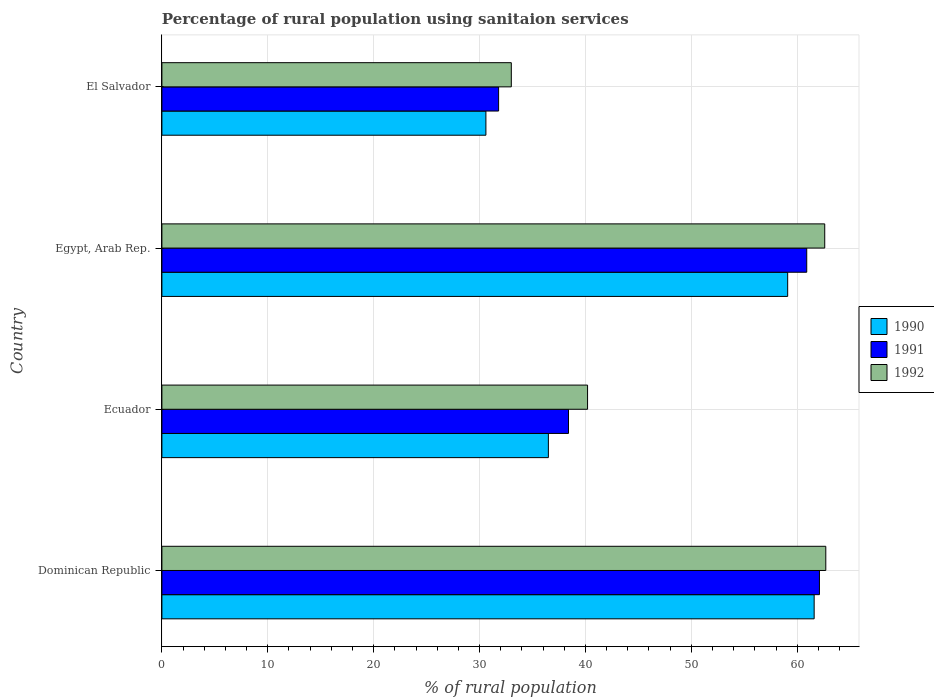How many groups of bars are there?
Your answer should be compact. 4. How many bars are there on the 4th tick from the bottom?
Your response must be concise. 3. What is the label of the 3rd group of bars from the top?
Your response must be concise. Ecuador. What is the percentage of rural population using sanitaion services in 1991 in Ecuador?
Give a very brief answer. 38.4. Across all countries, what is the maximum percentage of rural population using sanitaion services in 1991?
Offer a very short reply. 62.1. Across all countries, what is the minimum percentage of rural population using sanitaion services in 1991?
Ensure brevity in your answer.  31.8. In which country was the percentage of rural population using sanitaion services in 1990 maximum?
Offer a terse response. Dominican Republic. In which country was the percentage of rural population using sanitaion services in 1990 minimum?
Offer a terse response. El Salvador. What is the total percentage of rural population using sanitaion services in 1992 in the graph?
Offer a very short reply. 198.5. What is the difference between the percentage of rural population using sanitaion services in 1992 in Ecuador and that in El Salvador?
Offer a very short reply. 7.2. What is the difference between the percentage of rural population using sanitaion services in 1990 in El Salvador and the percentage of rural population using sanitaion services in 1992 in Dominican Republic?
Provide a succinct answer. -32.1. What is the average percentage of rural population using sanitaion services in 1990 per country?
Your response must be concise. 46.95. What is the difference between the percentage of rural population using sanitaion services in 1990 and percentage of rural population using sanitaion services in 1991 in Egypt, Arab Rep.?
Your answer should be compact. -1.8. In how many countries, is the percentage of rural population using sanitaion services in 1991 greater than 36 %?
Provide a succinct answer. 3. What is the ratio of the percentage of rural population using sanitaion services in 1991 in Dominican Republic to that in El Salvador?
Provide a short and direct response. 1.95. Is the difference between the percentage of rural population using sanitaion services in 1990 in Egypt, Arab Rep. and El Salvador greater than the difference between the percentage of rural population using sanitaion services in 1991 in Egypt, Arab Rep. and El Salvador?
Give a very brief answer. No. What is the difference between the highest and the second highest percentage of rural population using sanitaion services in 1992?
Provide a succinct answer. 0.1. What is the difference between the highest and the lowest percentage of rural population using sanitaion services in 1991?
Give a very brief answer. 30.3. In how many countries, is the percentage of rural population using sanitaion services in 1990 greater than the average percentage of rural population using sanitaion services in 1990 taken over all countries?
Ensure brevity in your answer.  2. Are all the bars in the graph horizontal?
Your response must be concise. Yes. How many countries are there in the graph?
Your response must be concise. 4. What is the difference between two consecutive major ticks on the X-axis?
Keep it short and to the point. 10. Does the graph contain any zero values?
Offer a very short reply. No. Does the graph contain grids?
Ensure brevity in your answer.  Yes. Where does the legend appear in the graph?
Offer a terse response. Center right. How many legend labels are there?
Ensure brevity in your answer.  3. How are the legend labels stacked?
Make the answer very short. Vertical. What is the title of the graph?
Provide a succinct answer. Percentage of rural population using sanitaion services. What is the label or title of the X-axis?
Offer a terse response. % of rural population. What is the % of rural population of 1990 in Dominican Republic?
Your response must be concise. 61.6. What is the % of rural population in 1991 in Dominican Republic?
Your answer should be very brief. 62.1. What is the % of rural population of 1992 in Dominican Republic?
Make the answer very short. 62.7. What is the % of rural population in 1990 in Ecuador?
Offer a terse response. 36.5. What is the % of rural population in 1991 in Ecuador?
Make the answer very short. 38.4. What is the % of rural population in 1992 in Ecuador?
Give a very brief answer. 40.2. What is the % of rural population in 1990 in Egypt, Arab Rep.?
Make the answer very short. 59.1. What is the % of rural population of 1991 in Egypt, Arab Rep.?
Your answer should be compact. 60.9. What is the % of rural population of 1992 in Egypt, Arab Rep.?
Your answer should be compact. 62.6. What is the % of rural population of 1990 in El Salvador?
Offer a terse response. 30.6. What is the % of rural population in 1991 in El Salvador?
Provide a short and direct response. 31.8. What is the % of rural population of 1992 in El Salvador?
Provide a succinct answer. 33. Across all countries, what is the maximum % of rural population in 1990?
Your answer should be compact. 61.6. Across all countries, what is the maximum % of rural population of 1991?
Offer a terse response. 62.1. Across all countries, what is the maximum % of rural population in 1992?
Your answer should be very brief. 62.7. Across all countries, what is the minimum % of rural population of 1990?
Your response must be concise. 30.6. Across all countries, what is the minimum % of rural population of 1991?
Ensure brevity in your answer.  31.8. What is the total % of rural population of 1990 in the graph?
Give a very brief answer. 187.8. What is the total % of rural population of 1991 in the graph?
Your response must be concise. 193.2. What is the total % of rural population in 1992 in the graph?
Your response must be concise. 198.5. What is the difference between the % of rural population of 1990 in Dominican Republic and that in Ecuador?
Give a very brief answer. 25.1. What is the difference between the % of rural population of 1991 in Dominican Republic and that in Ecuador?
Offer a very short reply. 23.7. What is the difference between the % of rural population of 1992 in Dominican Republic and that in Ecuador?
Ensure brevity in your answer.  22.5. What is the difference between the % of rural population in 1991 in Dominican Republic and that in Egypt, Arab Rep.?
Your response must be concise. 1.2. What is the difference between the % of rural population of 1990 in Dominican Republic and that in El Salvador?
Ensure brevity in your answer.  31. What is the difference between the % of rural population in 1991 in Dominican Republic and that in El Salvador?
Offer a terse response. 30.3. What is the difference between the % of rural population in 1992 in Dominican Republic and that in El Salvador?
Offer a very short reply. 29.7. What is the difference between the % of rural population in 1990 in Ecuador and that in Egypt, Arab Rep.?
Make the answer very short. -22.6. What is the difference between the % of rural population of 1991 in Ecuador and that in Egypt, Arab Rep.?
Provide a short and direct response. -22.5. What is the difference between the % of rural population of 1992 in Ecuador and that in Egypt, Arab Rep.?
Make the answer very short. -22.4. What is the difference between the % of rural population in 1991 in Ecuador and that in El Salvador?
Provide a short and direct response. 6.6. What is the difference between the % of rural population in 1992 in Ecuador and that in El Salvador?
Your answer should be compact. 7.2. What is the difference between the % of rural population of 1990 in Egypt, Arab Rep. and that in El Salvador?
Provide a succinct answer. 28.5. What is the difference between the % of rural population of 1991 in Egypt, Arab Rep. and that in El Salvador?
Provide a short and direct response. 29.1. What is the difference between the % of rural population in 1992 in Egypt, Arab Rep. and that in El Salvador?
Your response must be concise. 29.6. What is the difference between the % of rural population of 1990 in Dominican Republic and the % of rural population of 1991 in Ecuador?
Offer a terse response. 23.2. What is the difference between the % of rural population in 1990 in Dominican Republic and the % of rural population in 1992 in Ecuador?
Ensure brevity in your answer.  21.4. What is the difference between the % of rural population of 1991 in Dominican Republic and the % of rural population of 1992 in Ecuador?
Your answer should be compact. 21.9. What is the difference between the % of rural population in 1990 in Dominican Republic and the % of rural population in 1992 in Egypt, Arab Rep.?
Offer a terse response. -1. What is the difference between the % of rural population in 1991 in Dominican Republic and the % of rural population in 1992 in Egypt, Arab Rep.?
Keep it short and to the point. -0.5. What is the difference between the % of rural population of 1990 in Dominican Republic and the % of rural population of 1991 in El Salvador?
Provide a succinct answer. 29.8. What is the difference between the % of rural population in 1990 in Dominican Republic and the % of rural population in 1992 in El Salvador?
Give a very brief answer. 28.6. What is the difference between the % of rural population of 1991 in Dominican Republic and the % of rural population of 1992 in El Salvador?
Your answer should be very brief. 29.1. What is the difference between the % of rural population of 1990 in Ecuador and the % of rural population of 1991 in Egypt, Arab Rep.?
Provide a succinct answer. -24.4. What is the difference between the % of rural population in 1990 in Ecuador and the % of rural population in 1992 in Egypt, Arab Rep.?
Offer a terse response. -26.1. What is the difference between the % of rural population of 1991 in Ecuador and the % of rural population of 1992 in Egypt, Arab Rep.?
Provide a succinct answer. -24.2. What is the difference between the % of rural population in 1990 in Ecuador and the % of rural population in 1991 in El Salvador?
Offer a terse response. 4.7. What is the difference between the % of rural population in 1990 in Ecuador and the % of rural population in 1992 in El Salvador?
Your answer should be compact. 3.5. What is the difference between the % of rural population in 1990 in Egypt, Arab Rep. and the % of rural population in 1991 in El Salvador?
Your answer should be very brief. 27.3. What is the difference between the % of rural population of 1990 in Egypt, Arab Rep. and the % of rural population of 1992 in El Salvador?
Make the answer very short. 26.1. What is the difference between the % of rural population in 1991 in Egypt, Arab Rep. and the % of rural population in 1992 in El Salvador?
Provide a succinct answer. 27.9. What is the average % of rural population of 1990 per country?
Your answer should be compact. 46.95. What is the average % of rural population of 1991 per country?
Make the answer very short. 48.3. What is the average % of rural population of 1992 per country?
Ensure brevity in your answer.  49.62. What is the difference between the % of rural population in 1990 and % of rural population in 1991 in Dominican Republic?
Offer a very short reply. -0.5. What is the difference between the % of rural population of 1990 and % of rural population of 1991 in Ecuador?
Ensure brevity in your answer.  -1.9. What is the difference between the % of rural population in 1990 and % of rural population in 1992 in Ecuador?
Make the answer very short. -3.7. What is the difference between the % of rural population in 1991 and % of rural population in 1992 in Ecuador?
Your response must be concise. -1.8. What is the difference between the % of rural population in 1990 and % of rural population in 1991 in Egypt, Arab Rep.?
Make the answer very short. -1.8. What is the difference between the % of rural population of 1990 and % of rural population of 1992 in Egypt, Arab Rep.?
Provide a succinct answer. -3.5. What is the difference between the % of rural population in 1991 and % of rural population in 1992 in Egypt, Arab Rep.?
Give a very brief answer. -1.7. What is the difference between the % of rural population of 1990 and % of rural population of 1991 in El Salvador?
Ensure brevity in your answer.  -1.2. What is the difference between the % of rural population in 1990 and % of rural population in 1992 in El Salvador?
Keep it short and to the point. -2.4. What is the difference between the % of rural population of 1991 and % of rural population of 1992 in El Salvador?
Give a very brief answer. -1.2. What is the ratio of the % of rural population in 1990 in Dominican Republic to that in Ecuador?
Give a very brief answer. 1.69. What is the ratio of the % of rural population in 1991 in Dominican Republic to that in Ecuador?
Offer a very short reply. 1.62. What is the ratio of the % of rural population in 1992 in Dominican Republic to that in Ecuador?
Your answer should be very brief. 1.56. What is the ratio of the % of rural population of 1990 in Dominican Republic to that in Egypt, Arab Rep.?
Provide a succinct answer. 1.04. What is the ratio of the % of rural population in 1991 in Dominican Republic to that in Egypt, Arab Rep.?
Offer a terse response. 1.02. What is the ratio of the % of rural population in 1992 in Dominican Republic to that in Egypt, Arab Rep.?
Make the answer very short. 1. What is the ratio of the % of rural population of 1990 in Dominican Republic to that in El Salvador?
Give a very brief answer. 2.01. What is the ratio of the % of rural population in 1991 in Dominican Republic to that in El Salvador?
Give a very brief answer. 1.95. What is the ratio of the % of rural population of 1990 in Ecuador to that in Egypt, Arab Rep.?
Your response must be concise. 0.62. What is the ratio of the % of rural population in 1991 in Ecuador to that in Egypt, Arab Rep.?
Make the answer very short. 0.63. What is the ratio of the % of rural population of 1992 in Ecuador to that in Egypt, Arab Rep.?
Give a very brief answer. 0.64. What is the ratio of the % of rural population in 1990 in Ecuador to that in El Salvador?
Keep it short and to the point. 1.19. What is the ratio of the % of rural population in 1991 in Ecuador to that in El Salvador?
Your response must be concise. 1.21. What is the ratio of the % of rural population of 1992 in Ecuador to that in El Salvador?
Provide a short and direct response. 1.22. What is the ratio of the % of rural population in 1990 in Egypt, Arab Rep. to that in El Salvador?
Provide a succinct answer. 1.93. What is the ratio of the % of rural population in 1991 in Egypt, Arab Rep. to that in El Salvador?
Make the answer very short. 1.92. What is the ratio of the % of rural population in 1992 in Egypt, Arab Rep. to that in El Salvador?
Keep it short and to the point. 1.9. What is the difference between the highest and the second highest % of rural population in 1992?
Give a very brief answer. 0.1. What is the difference between the highest and the lowest % of rural population in 1990?
Provide a short and direct response. 31. What is the difference between the highest and the lowest % of rural population in 1991?
Keep it short and to the point. 30.3. What is the difference between the highest and the lowest % of rural population in 1992?
Your answer should be compact. 29.7. 